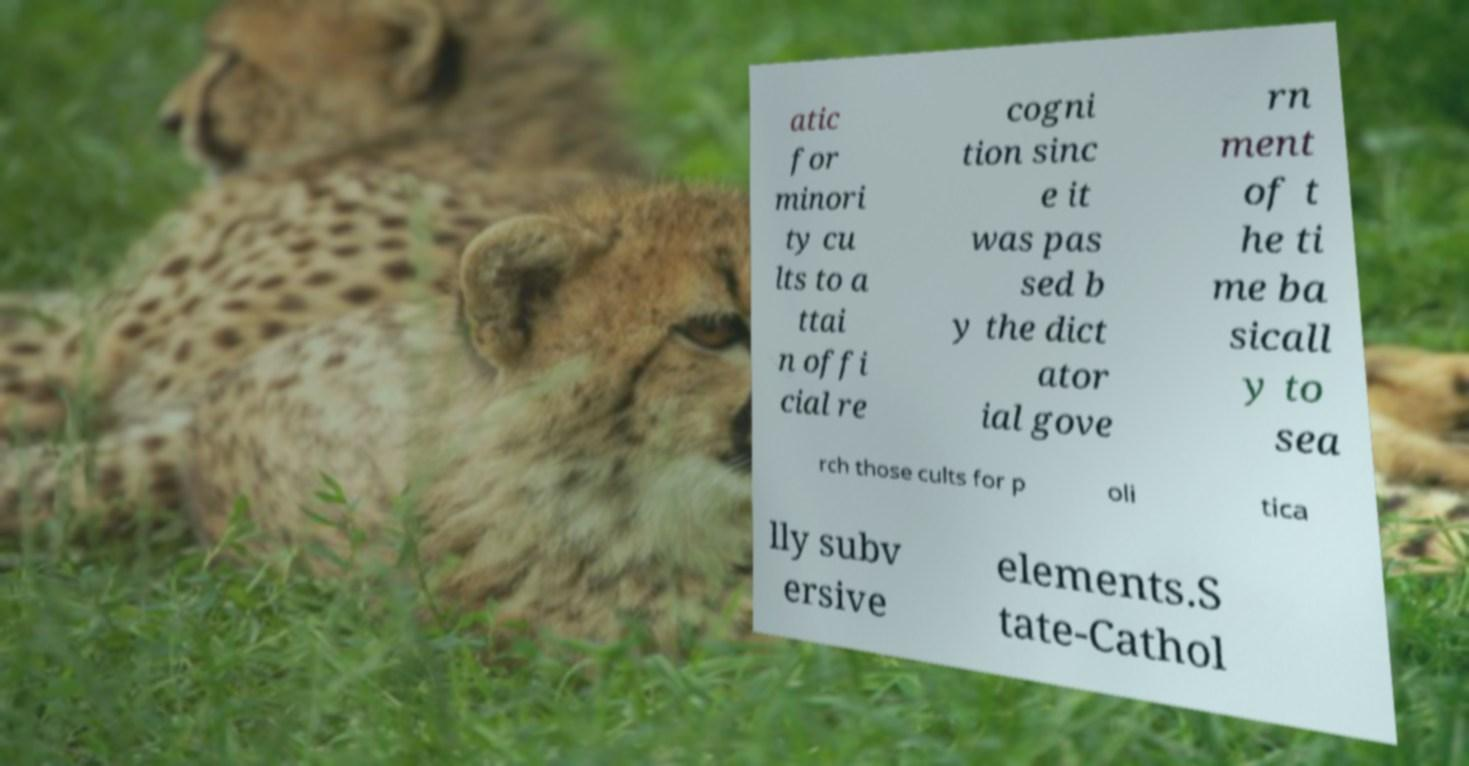Please read and relay the text visible in this image. What does it say? atic for minori ty cu lts to a ttai n offi cial re cogni tion sinc e it was pas sed b y the dict ator ial gove rn ment of t he ti me ba sicall y to sea rch those cults for p oli tica lly subv ersive elements.S tate-Cathol 